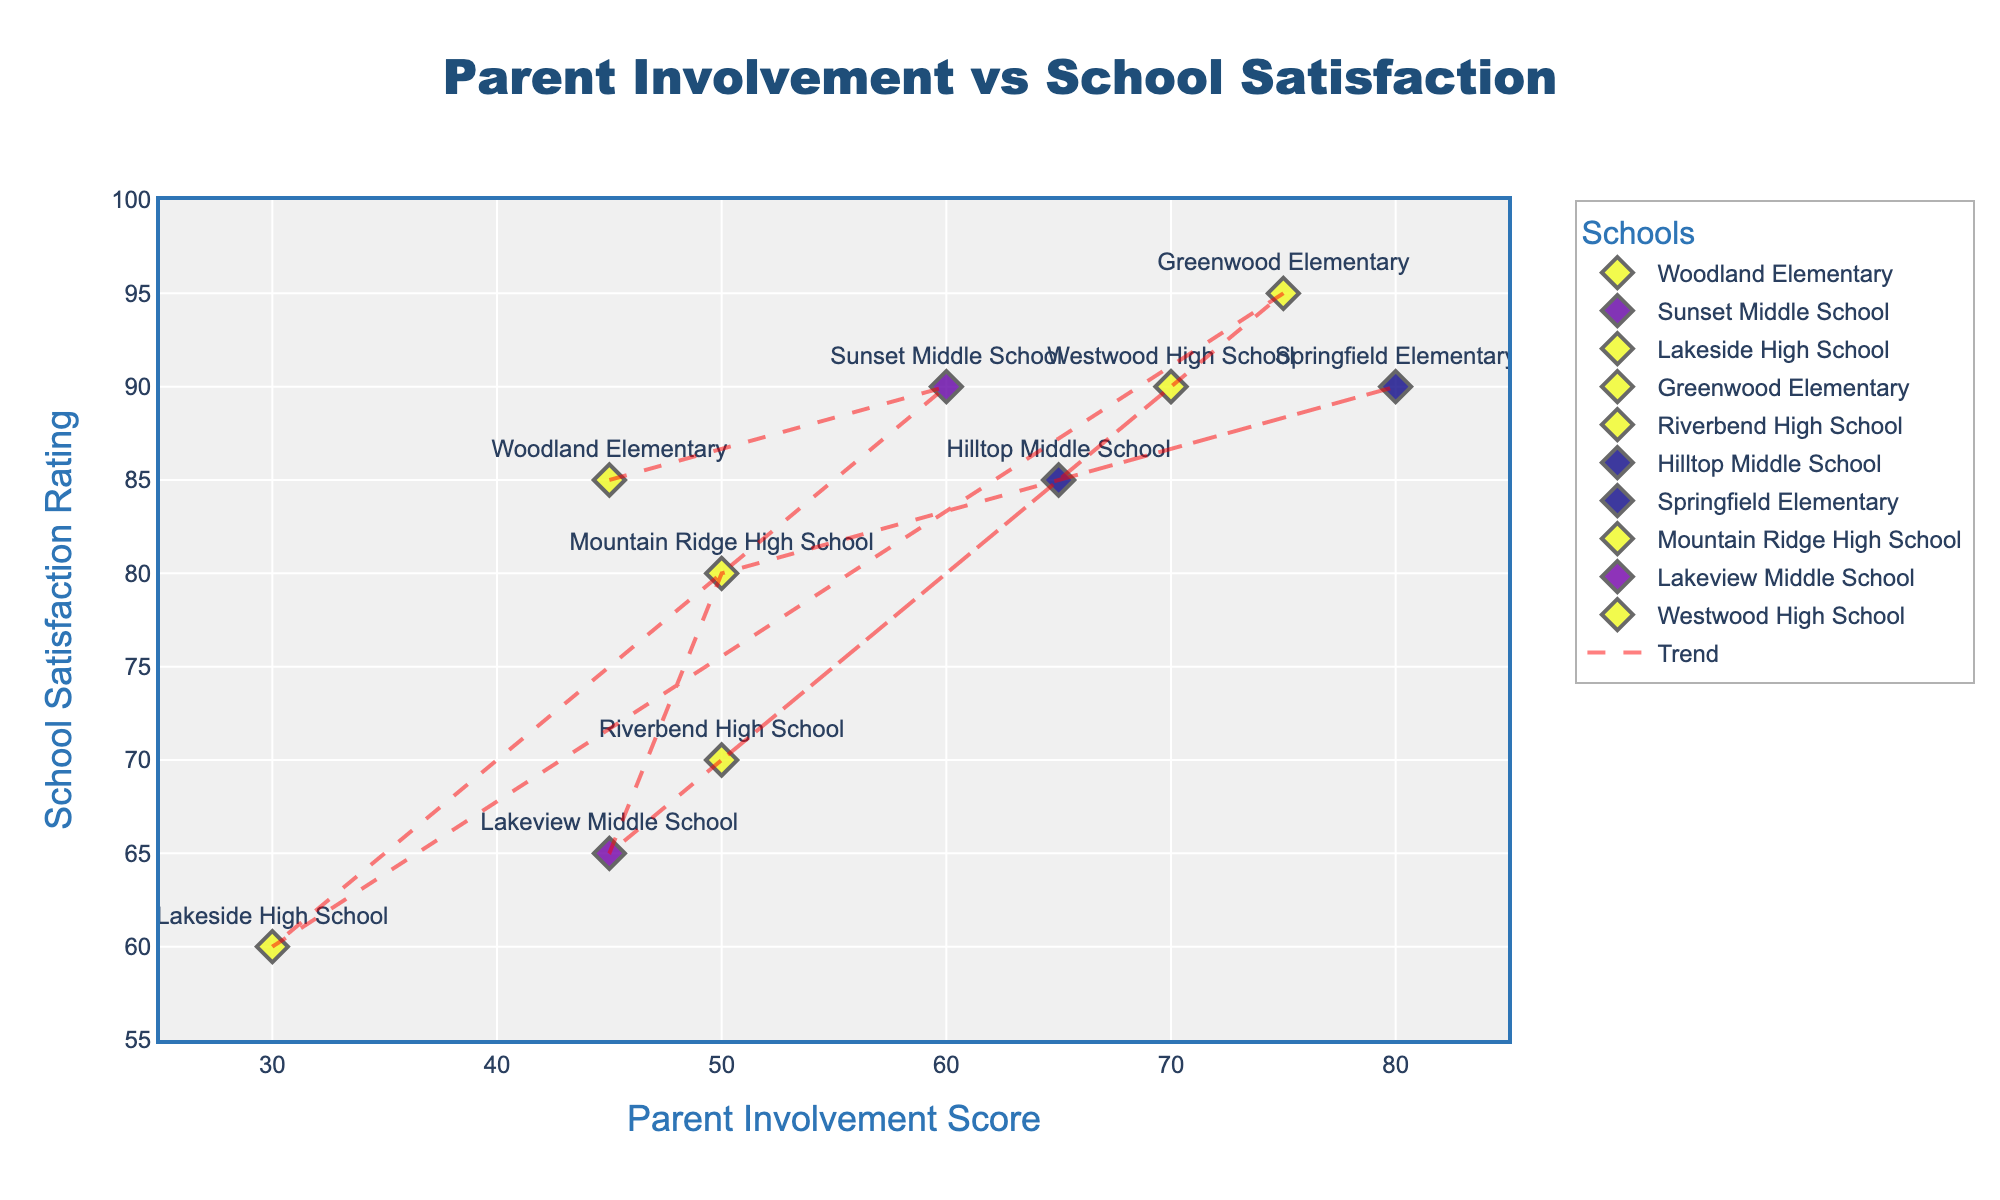What's the title of the scatter plot? The title of the scatter plot is clearly displayed at the top center of the figure.
Answer: Parent Involvement vs School Satisfaction What is the x-axis labeled as? The label of the x-axis is written below the x-axis line on the plot.
Answer: Parent Involvement Score How many schools have a parent involvement score of above 60? By looking at the x-axis and counting the number of schools with parent involvement score above 60: Schools are Sunset Middle School, Greenwood Elementary, Hilltop Middle School, Springfield Elementary, and Westwood High School.
Answer: 5 Which school has the highest school satisfaction rating, and what is the corresponding parent involvement score? The highest satisfaction rating appears at the top of the y-axis at 95, which is paired directly with Greenwood Elementary whose involvement score is 75.
Answer: Greenwood Elementary (75) What is the trend in the relationship between parent involvement and school satisfaction rating? The trendline added to the scatter plot shows a dashed red line moving upwards from left to right indicating that generally, as parent involvement increases, the satisfaction rating also increases.
Answer: Positive correlation Which school has the lowest parent involvement and what is its satisfaction rating? By locating the leftmost point on the x-axis, Lakeside High School has the lowest parent involvement of 30, and its corresponding satisfaction rating is 60.
Answer: Lakeside High School (60) Comparing Hilltop Middle School and Springfield Elementary, which school has higher parent involvement, and by how much? Hilltop Middle School has a parent involvement score of 65 and Springfield Elementary has 80. The difference is 80 - 65.
Answer: Springfield Elementary by 15 Between Riverbend High School and Mountain Ridge High School, which one has a higher satisfaction rating, and what is the difference? Riverbend High School has a satisfaction rating of 70 while Mountain Ridge High School has 80. The difference is 80 - 70.
Answer: Mountain Ridge High School by 10 What is the average parent involvement score for all schools? Sum all parent involvement scores: 45 + 60 + 30 + 75 + 50 + 65 + 80 + 50 + 45 + 70 = 570, then divide by the number of schools (10).
Answer: 57 Do any schools have the same parent involvement score, and if so, which ones? From the scatter plot, Woodland Elementary and Lakeview Middle School both have a parent involvement score of 45, and Riverbend High School and Mountain Ridge High School both have a score of 50.
Answer: Yes, Woodland Elementary and Lakeview Middle School (45), Riverbend High School and Mountain Ridge High School (50) 